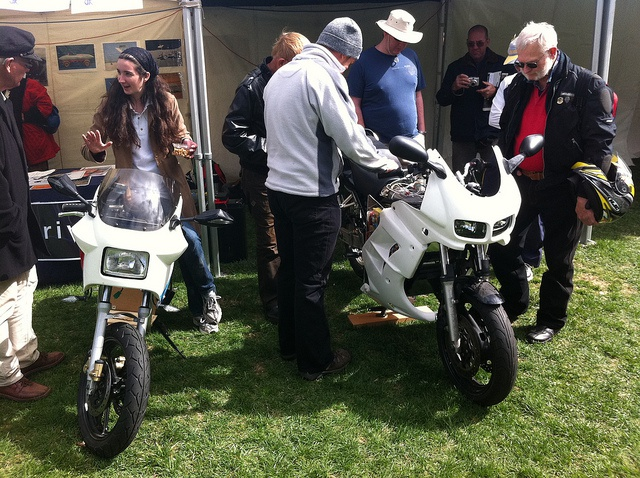Describe the objects in this image and their specific colors. I can see motorcycle in ivory, black, white, gray, and darkgray tones, people in ivory, black, lightgray, darkgray, and gray tones, motorcycle in ivory, black, white, gray, and darkgray tones, people in ivory, black, gray, white, and maroon tones, and people in ivory, black, gray, and maroon tones in this image. 